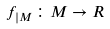<formula> <loc_0><loc_0><loc_500><loc_500>f _ { | M } \colon M \rightarrow R</formula> 